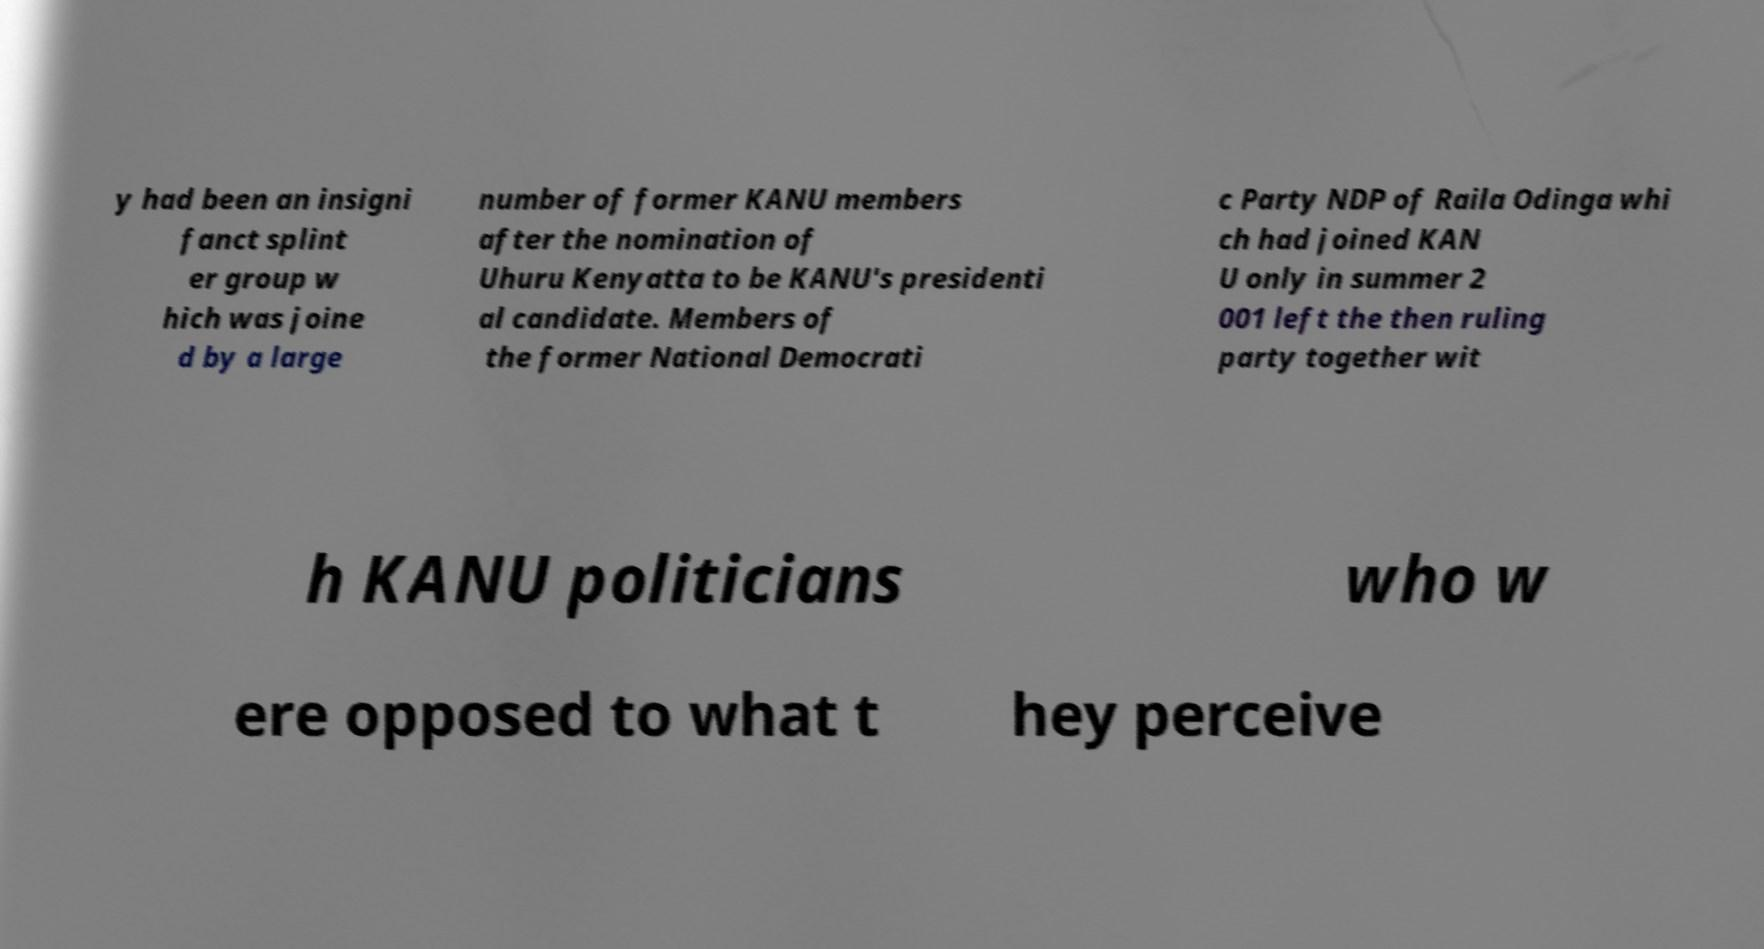Please identify and transcribe the text found in this image. y had been an insigni fanct splint er group w hich was joine d by a large number of former KANU members after the nomination of Uhuru Kenyatta to be KANU's presidenti al candidate. Members of the former National Democrati c Party NDP of Raila Odinga whi ch had joined KAN U only in summer 2 001 left the then ruling party together wit h KANU politicians who w ere opposed to what t hey perceive 